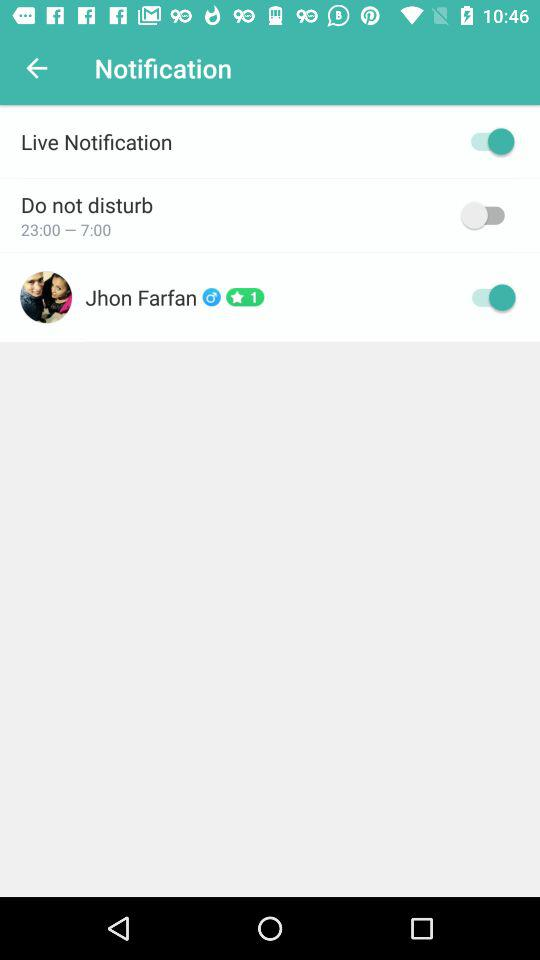What is the gender of user?
When the provided information is insufficient, respond with <no answer>. <no answer> 